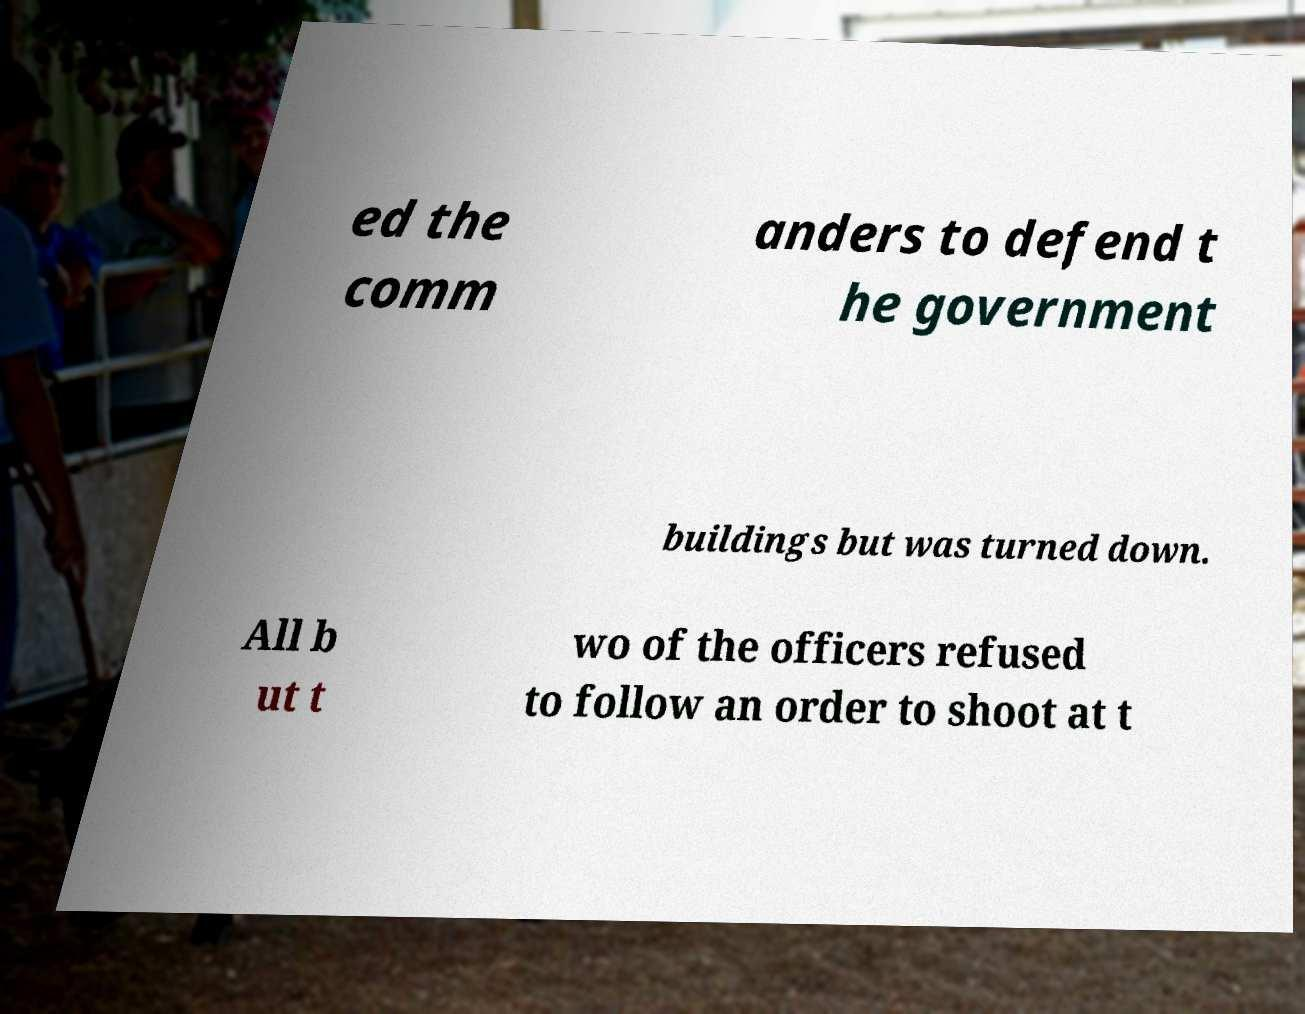For documentation purposes, I need the text within this image transcribed. Could you provide that? ed the comm anders to defend t he government buildings but was turned down. All b ut t wo of the officers refused to follow an order to shoot at t 